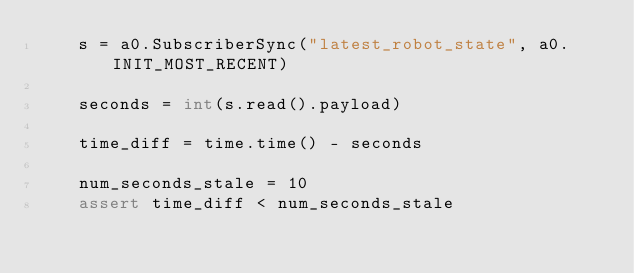<code> <loc_0><loc_0><loc_500><loc_500><_Python_>    s = a0.SubscriberSync("latest_robot_state", a0.INIT_MOST_RECENT)

    seconds = int(s.read().payload)

    time_diff = time.time() - seconds

    num_seconds_stale = 10
    assert time_diff < num_seconds_stale
</code> 